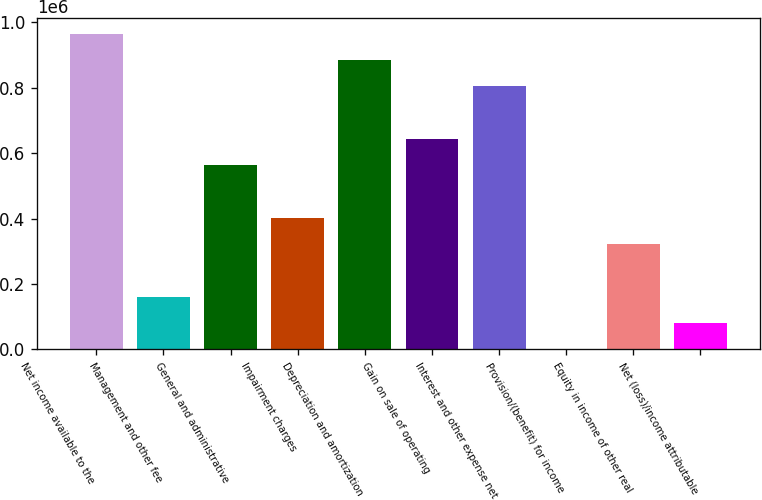Convert chart to OTSL. <chart><loc_0><loc_0><loc_500><loc_500><bar_chart><fcel>Net income available to the<fcel>Management and other fee<fcel>General and administrative<fcel>Impairment charges<fcel>Depreciation and amortization<fcel>Gain on sale of operating<fcel>Interest and other expense net<fcel>Provision/(benefit) for income<fcel>Equity in income of other real<fcel>Net (loss)/income attributable<nl><fcel>965202<fcel>161600<fcel>563401<fcel>402681<fcel>884842<fcel>643762<fcel>804482<fcel>880<fcel>322321<fcel>81240.2<nl></chart> 